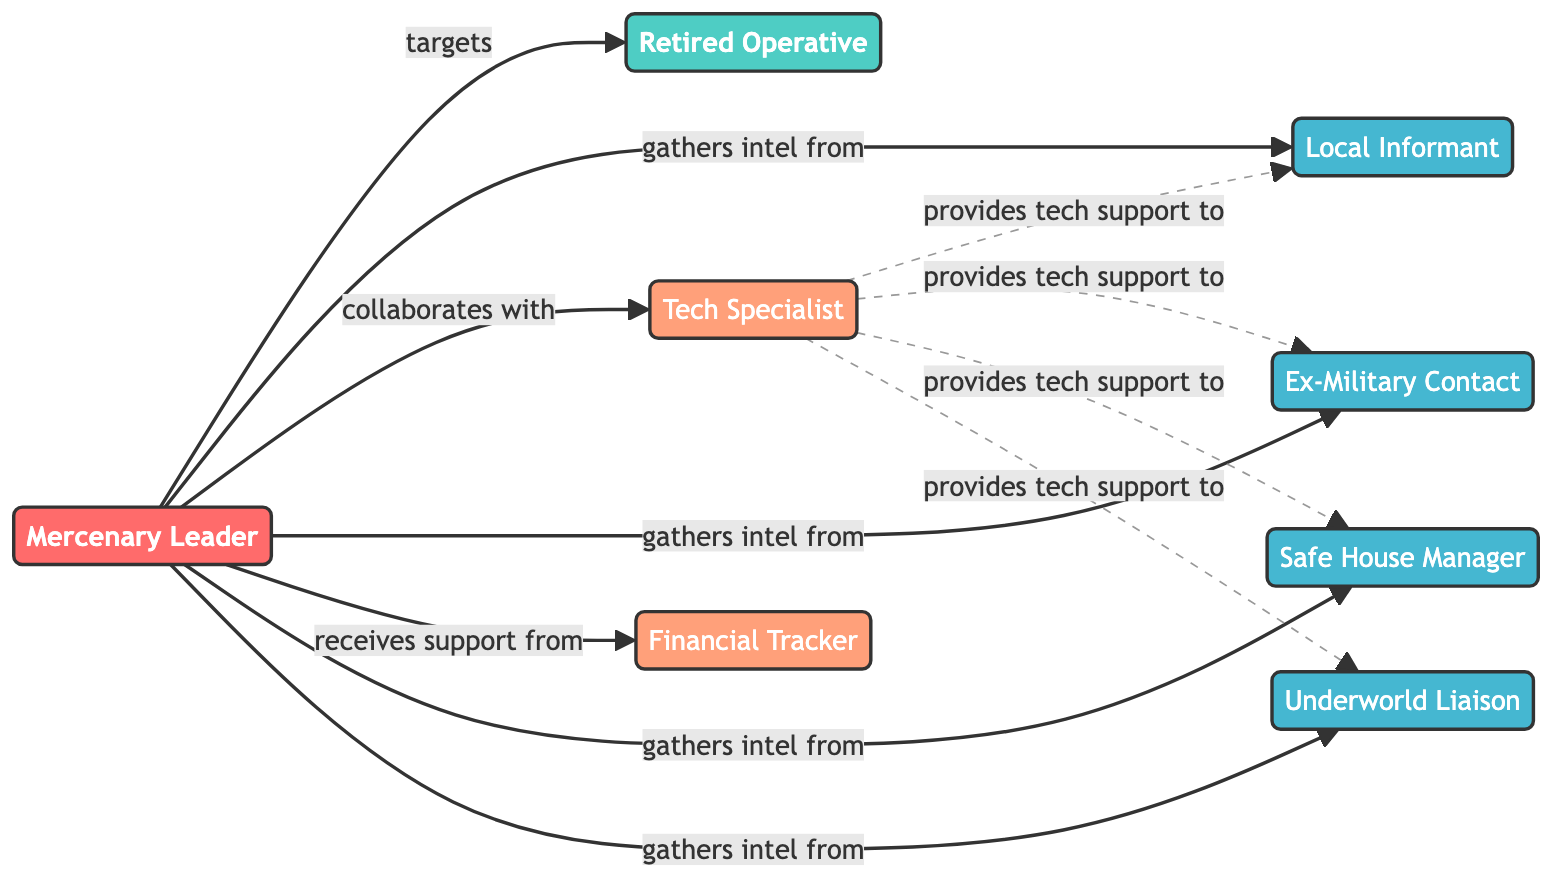What is the total number of nodes in the diagram? There are 8 distinct entities or roles in the diagram represented as nodes. These include the Mercenary Leader, Retired Operative, Local Informant, Tech Specialist, Ex-Military Contact, Financial Tracker, Safe House Manager, and Underworld Liaison. Counting these gives a total of 8 nodes.
Answer: 8 Who is the central target in this network? The central target in this network is the Retired Operative, as indicated by the edges that show all relationships and activities aimed at them. They are labeled as the primary focus (target) in the diagram.
Answer: Retired Operative How many informants are associated with the Mercenary Leader? The Mercenary Leader is connected to four informants: Local Informant, Ex-Military Contact, Safe House Manager, and Underworld Liaison. This is determined by counting the nodes that list "gathers intel from" leading to various informants.
Answer: 4 Which specialist collaborates with the Mercenary Leader? The Tech Specialist collaborates with the Mercenary Leader, as indicated by the direct connection labeled as "collaborates with" in the diagram.
Answer: Tech Specialist What type of support does the Mercenary Leader receive from the Financial Tracker? The connection labeled "receives support from" signifies that the Mercenary Leader benefits from assistance related to financial tracking or management. The type of support is therefore financial.
Answer: Financial Which node provides tech support to the Safe House Manager? The Tech Specialist is the node that provides tech support to the Safe House Manager, as shown by the edge labeled "provides tech support to" connecting them in the diagram.
Answer: Tech Specialist How many relationships does the Mercenary Leader have with informants? The Mercenary Leader is linked to four informants via connections that indicate "gathers intel from," thus illustrating there are four distinct relationships concerning informants.
Answer: 4 What is the relationship type between the Tech Specialist and the Local Informant? The relationship type between these two nodes is indicated as "provides tech support to," which illustrates that the Tech Specialist aids the Local Informant with technological assistance.
Answer: provides tech support to What color represents the strategist in the diagram? The strategist, which is the role of the Mercenary Leader, is represented by a color defined as fill:#FF6B6B. This detail is based on the class definition given for strategists in the diagram.
Answer: #FF6B6B 